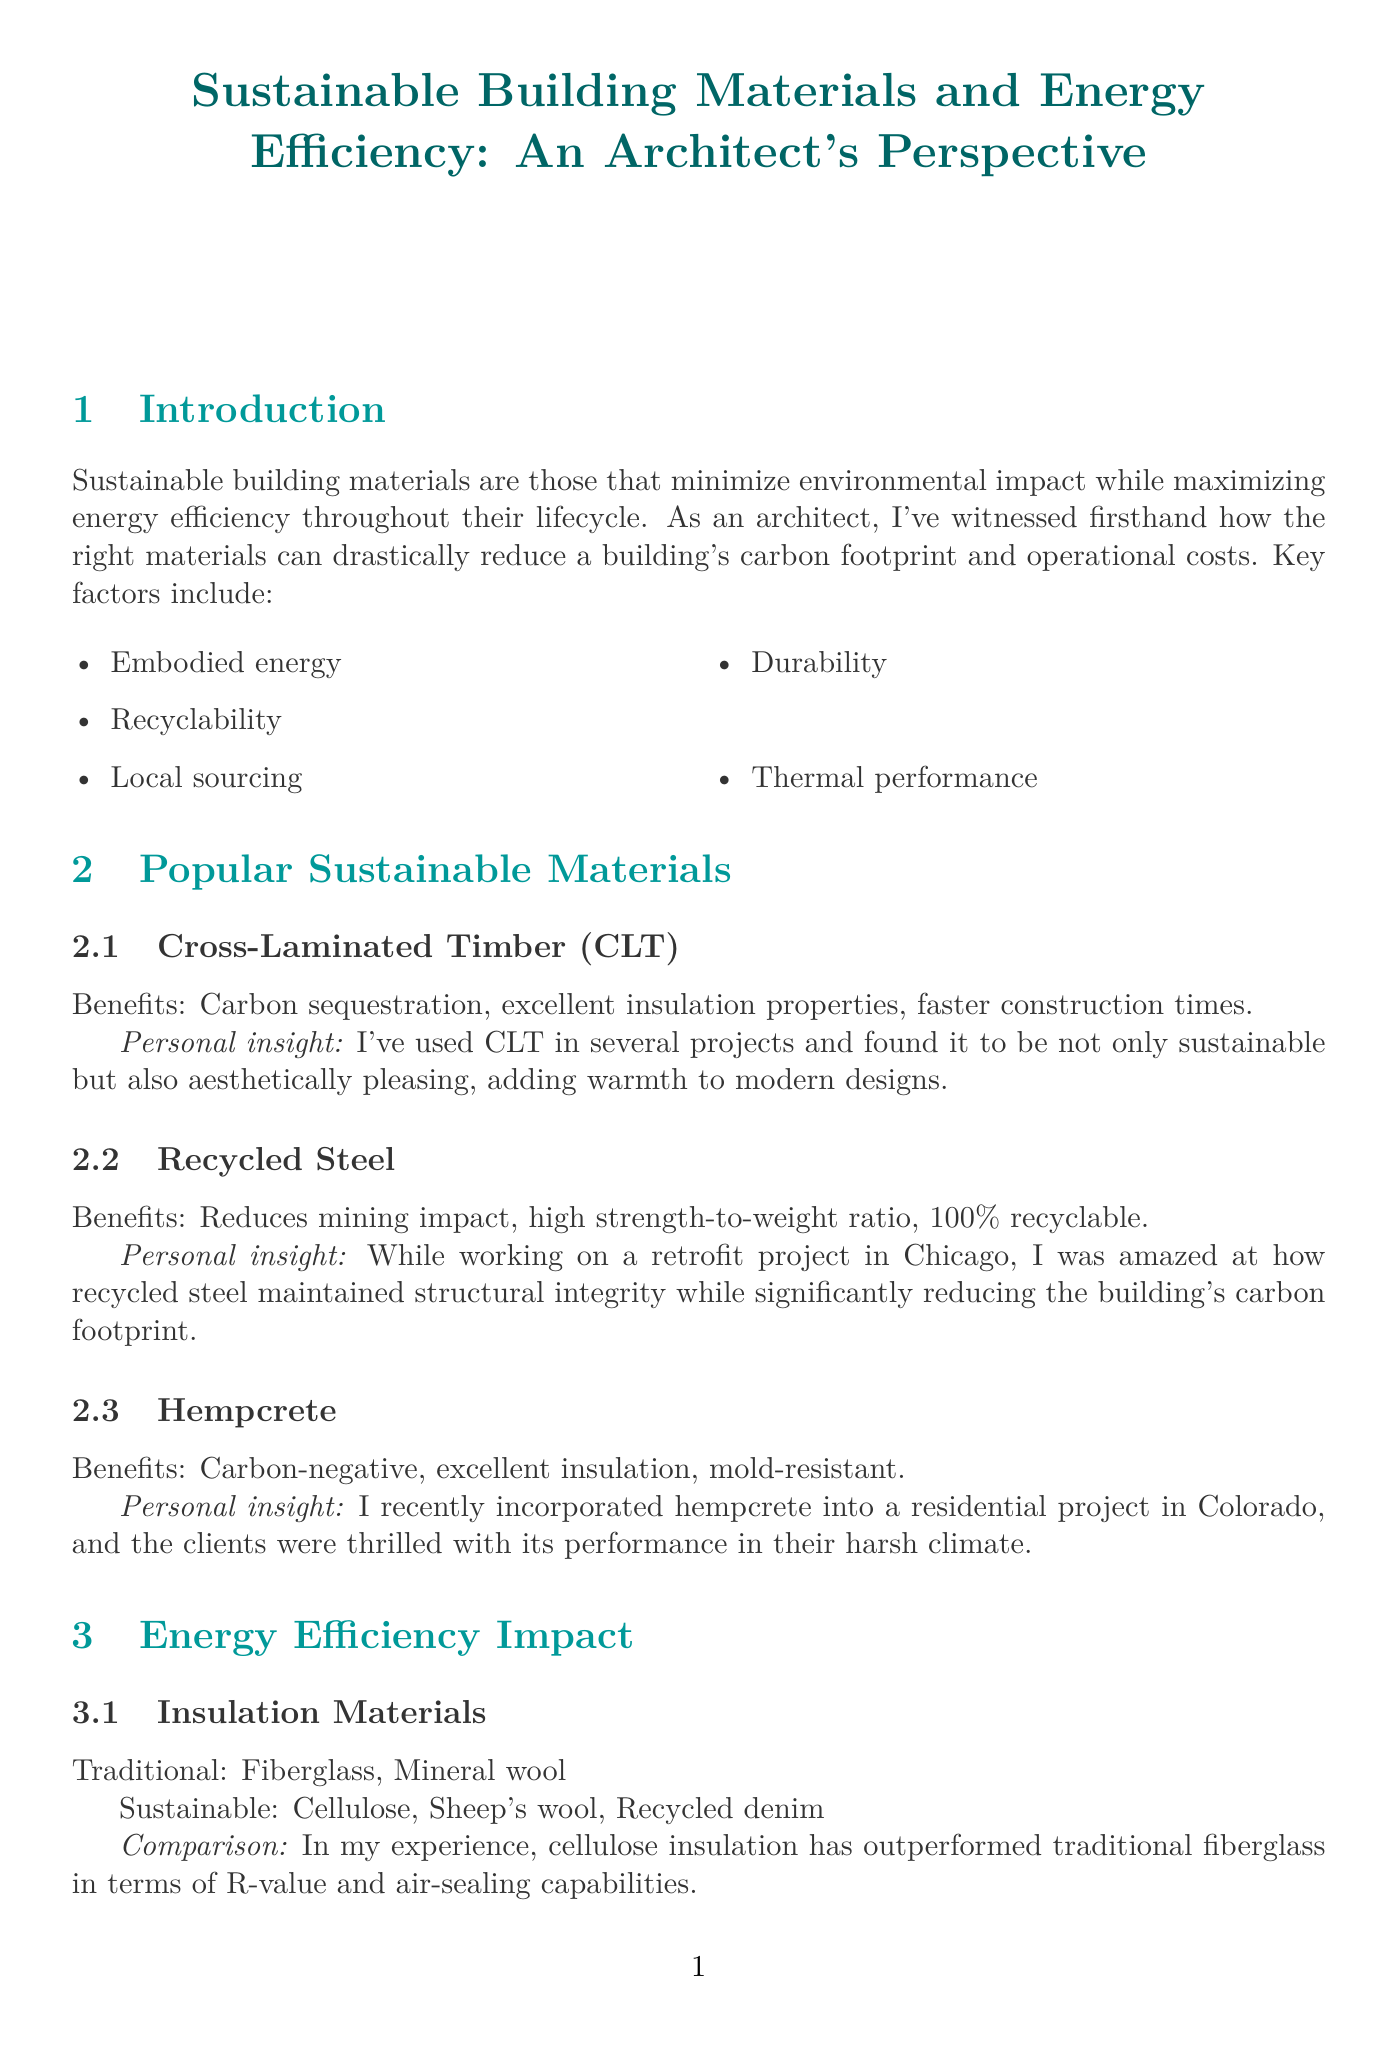What are sustainable building materials? Sustainable building materials are those that minimize environmental impact while maximizing energy efficiency throughout their lifecycle.
Answer: Sustainable building materials are those that minimize environmental impact while maximizing energy efficiency throughout their lifecycle Name a popular sustainable material mentioned in the report. The report lists several sustainable materials, including Cross-Laminated Timber (CLT), Recycled Steel, and Hempcrete.
Answer: Cross-Laminated Timber (CLT) What energy performance did The Bullitt Center achieve? The Bullitt Center achieved net-zero energy consumption, showcasing its energy efficiency.
Answer: Net-zero energy consumption How much can energy bills be reduced after retrofitting with high-performance windows? The report states energy bills can be reduced by up to 30% after retrofitting buildings with high-performance windows.
Answer: Up to 30% What is a challenge related to sustainable materials? The report identifies several challenges, one being the higher upfront costs for sustainable materials.
Answer: Higher upfront costs What is one future trend in sustainable building materials? The report outlines future trends including 3D-printed building components using recycled plastics.
Answer: 3D-printed building components using recycled plastics What personal approach does the architect take regarding building codes? The architect participates in city council meetings to educate officials on the benefits of updated, sustainability-focused building codes.
Answer: Educate officials on benefits of updated codes Which case study features a vertical forest facade? The case study of Bosco Verticale in Milan features a vertical forest facade as part of its sustainable design.
Answer: Bosco Verticale, Milan 